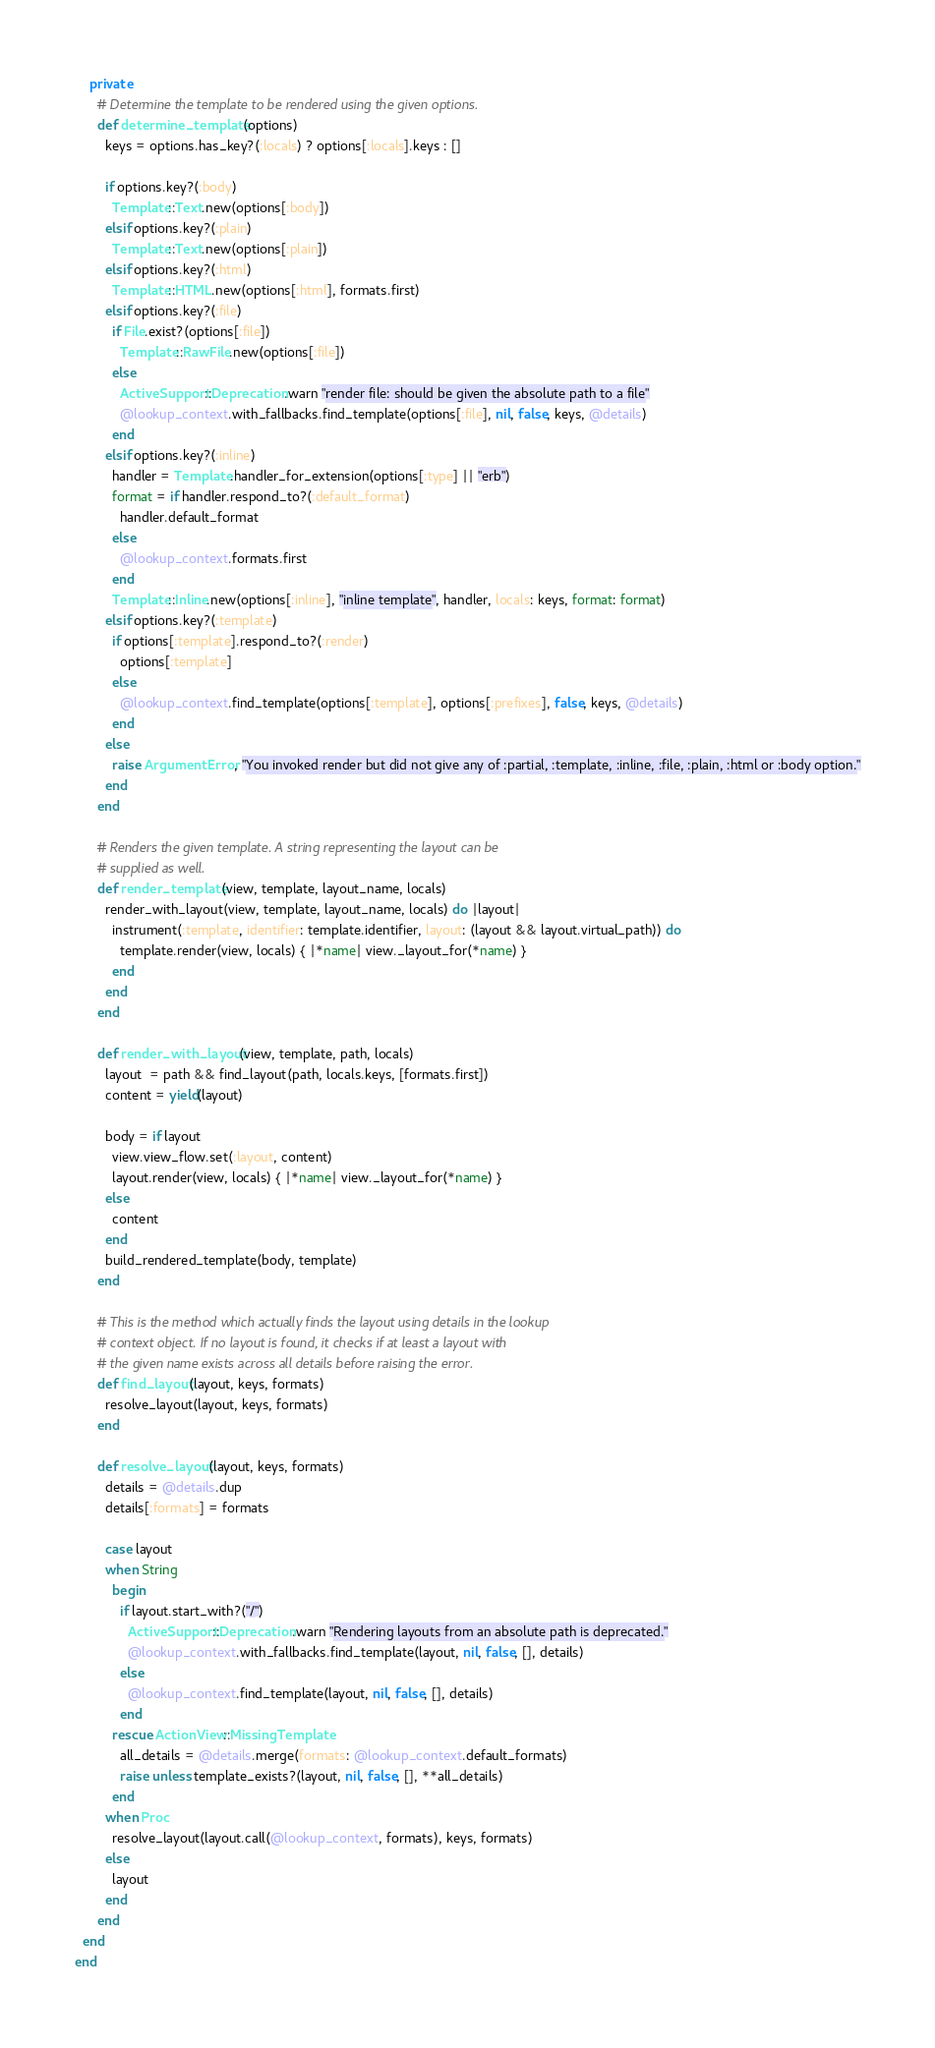Convert code to text. <code><loc_0><loc_0><loc_500><loc_500><_Ruby_>    private
      # Determine the template to be rendered using the given options.
      def determine_template(options)
        keys = options.has_key?(:locals) ? options[:locals].keys : []

        if options.key?(:body)
          Template::Text.new(options[:body])
        elsif options.key?(:plain)
          Template::Text.new(options[:plain])
        elsif options.key?(:html)
          Template::HTML.new(options[:html], formats.first)
        elsif options.key?(:file)
          if File.exist?(options[:file])
            Template::RawFile.new(options[:file])
          else
            ActiveSupport::Deprecation.warn "render file: should be given the absolute path to a file"
            @lookup_context.with_fallbacks.find_template(options[:file], nil, false, keys, @details)
          end
        elsif options.key?(:inline)
          handler = Template.handler_for_extension(options[:type] || "erb")
          format = if handler.respond_to?(:default_format)
            handler.default_format
          else
            @lookup_context.formats.first
          end
          Template::Inline.new(options[:inline], "inline template", handler, locals: keys, format: format)
        elsif options.key?(:template)
          if options[:template].respond_to?(:render)
            options[:template]
          else
            @lookup_context.find_template(options[:template], options[:prefixes], false, keys, @details)
          end
        else
          raise ArgumentError, "You invoked render but did not give any of :partial, :template, :inline, :file, :plain, :html or :body option."
        end
      end

      # Renders the given template. A string representing the layout can be
      # supplied as well.
      def render_template(view, template, layout_name, locals)
        render_with_layout(view, template, layout_name, locals) do |layout|
          instrument(:template, identifier: template.identifier, layout: (layout && layout.virtual_path)) do
            template.render(view, locals) { |*name| view._layout_for(*name) }
          end
        end
      end

      def render_with_layout(view, template, path, locals)
        layout  = path && find_layout(path, locals.keys, [formats.first])
        content = yield(layout)

        body = if layout
          view.view_flow.set(:layout, content)
          layout.render(view, locals) { |*name| view._layout_for(*name) }
        else
          content
        end
        build_rendered_template(body, template)
      end

      # This is the method which actually finds the layout using details in the lookup
      # context object. If no layout is found, it checks if at least a layout with
      # the given name exists across all details before raising the error.
      def find_layout(layout, keys, formats)
        resolve_layout(layout, keys, formats)
      end

      def resolve_layout(layout, keys, formats)
        details = @details.dup
        details[:formats] = formats

        case layout
        when String
          begin
            if layout.start_with?("/")
              ActiveSupport::Deprecation.warn "Rendering layouts from an absolute path is deprecated."
              @lookup_context.with_fallbacks.find_template(layout, nil, false, [], details)
            else
              @lookup_context.find_template(layout, nil, false, [], details)
            end
          rescue ActionView::MissingTemplate
            all_details = @details.merge(formats: @lookup_context.default_formats)
            raise unless template_exists?(layout, nil, false, [], **all_details)
          end
        when Proc
          resolve_layout(layout.call(@lookup_context, formats), keys, formats)
        else
          layout
        end
      end
  end
end
</code> 